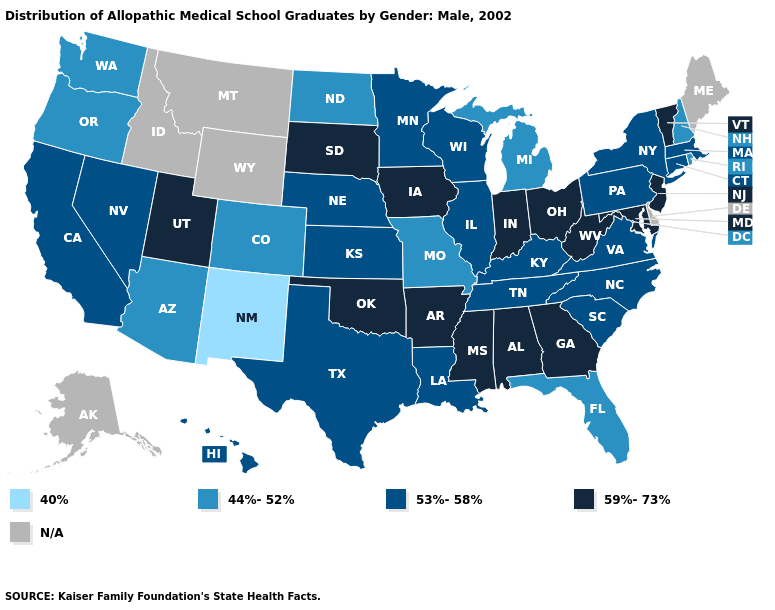What is the lowest value in the South?
Keep it brief. 44%-52%. Name the states that have a value in the range N/A?
Answer briefly. Alaska, Delaware, Idaho, Maine, Montana, Wyoming. Name the states that have a value in the range 44%-52%?
Keep it brief. Arizona, Colorado, Florida, Michigan, Missouri, New Hampshire, North Dakota, Oregon, Rhode Island, Washington. Among the states that border New Hampshire , does Massachusetts have the lowest value?
Give a very brief answer. Yes. What is the highest value in states that border Wisconsin?
Give a very brief answer. 59%-73%. Does Florida have the lowest value in the South?
Write a very short answer. Yes. Which states have the highest value in the USA?
Write a very short answer. Alabama, Arkansas, Georgia, Indiana, Iowa, Maryland, Mississippi, New Jersey, Ohio, Oklahoma, South Dakota, Utah, Vermont, West Virginia. Does New Mexico have the lowest value in the USA?
Be succinct. Yes. Name the states that have a value in the range N/A?
Be succinct. Alaska, Delaware, Idaho, Maine, Montana, Wyoming. How many symbols are there in the legend?
Write a very short answer. 5. What is the lowest value in the USA?
Keep it brief. 40%. Does New Hampshire have the lowest value in the Northeast?
Concise answer only. Yes. What is the value of Missouri?
Answer briefly. 44%-52%. Which states have the lowest value in the USA?
Be succinct. New Mexico. 